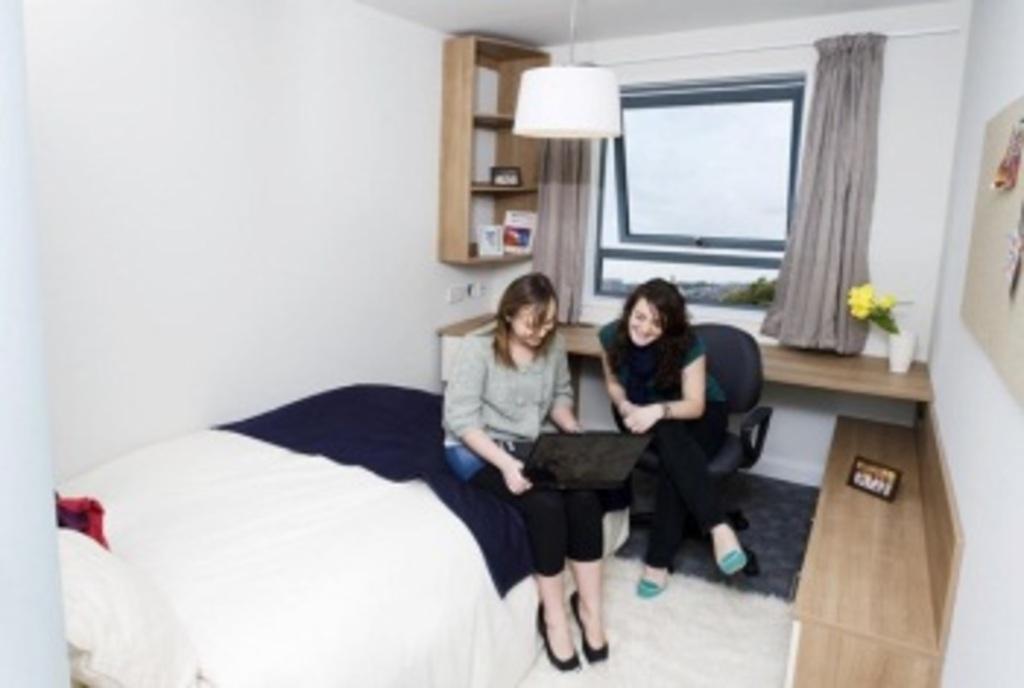Please provide a concise description of this image. In this image there are 2 persons sitting , and the back ground there is light, bed , blanket , pillow , photo frame , flower vase , curtain , window. 